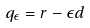<formula> <loc_0><loc_0><loc_500><loc_500>q _ { \epsilon } = r - \epsilon d</formula> 